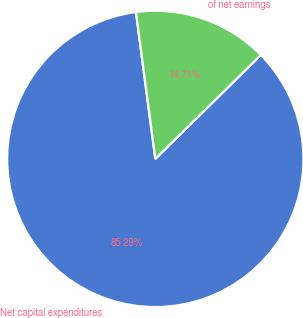<chart> <loc_0><loc_0><loc_500><loc_500><pie_chart><fcel>Net capital expenditures<fcel>of net earnings<nl><fcel>85.29%<fcel>14.71%<nl></chart> 